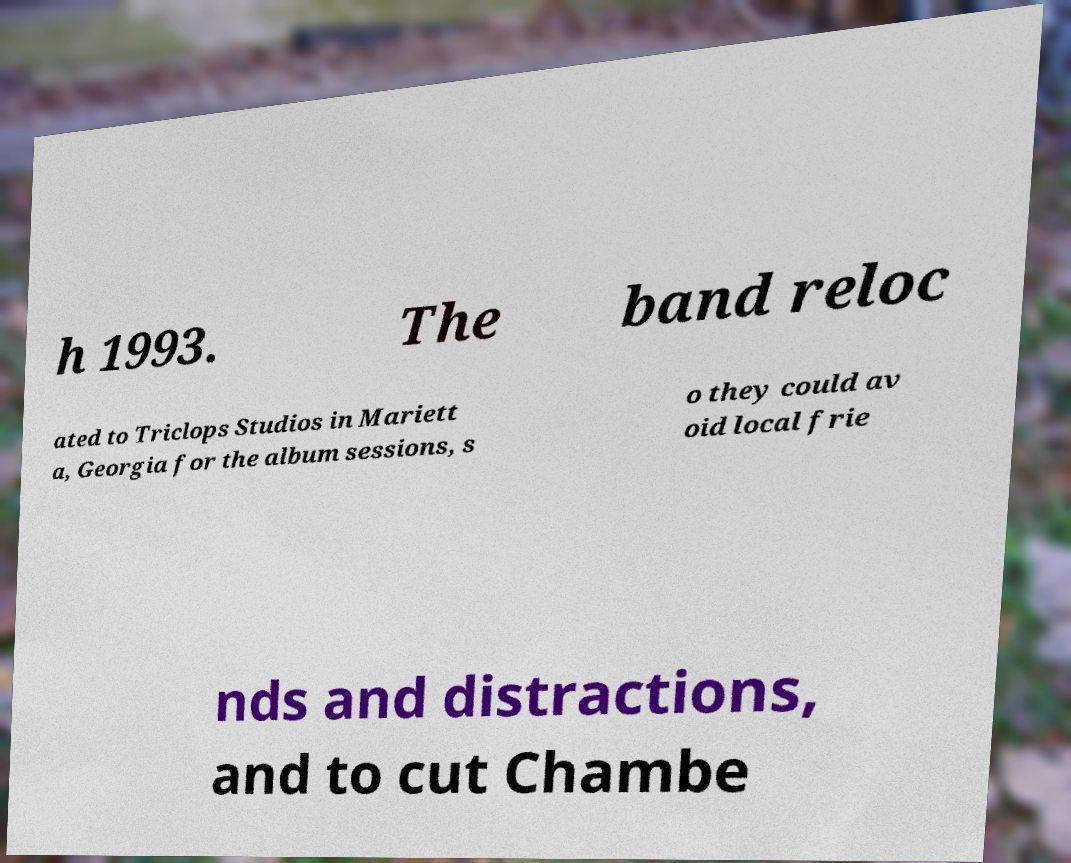Can you accurately transcribe the text from the provided image for me? h 1993. The band reloc ated to Triclops Studios in Mariett a, Georgia for the album sessions, s o they could av oid local frie nds and distractions, and to cut Chambe 